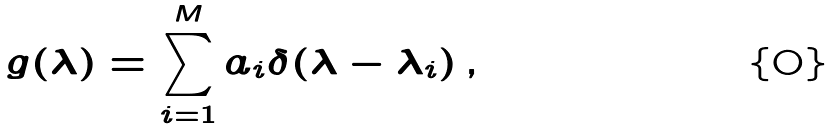<formula> <loc_0><loc_0><loc_500><loc_500>g ( \lambda ) = \sum _ { i = 1 } ^ { M } a _ { i } \delta ( \lambda - \lambda _ { i } ) \, ,</formula> 